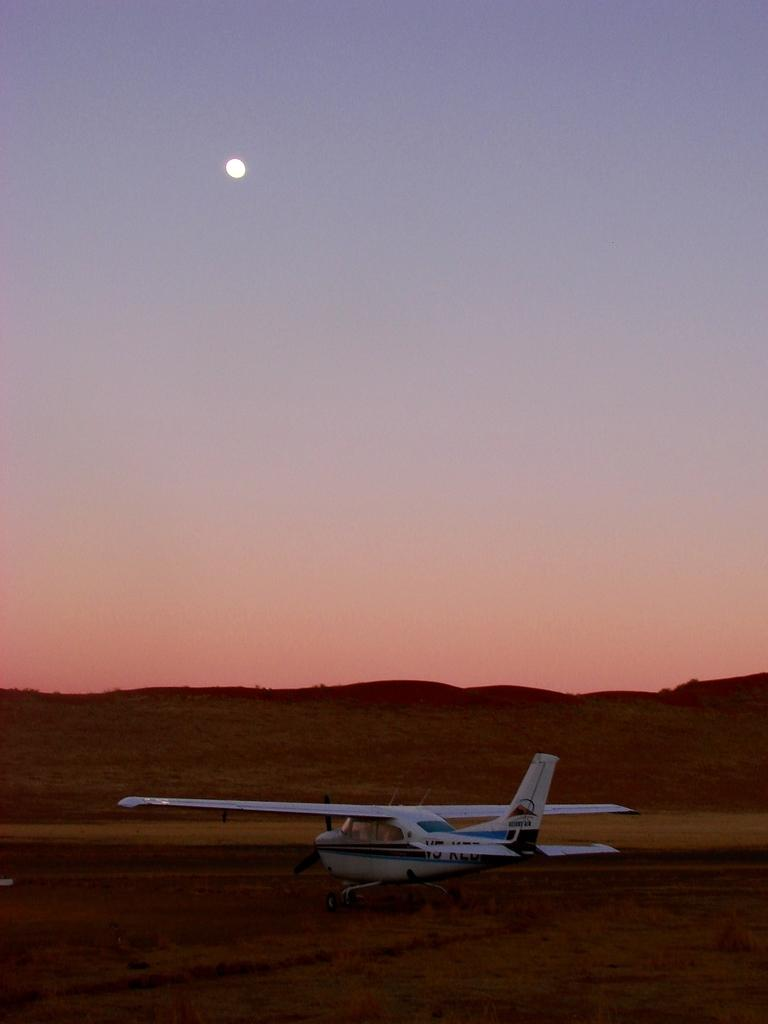What is the main subject in the foreground of the image? There is a helicopter in the foreground of the image. What can be seen in the middle of the image? There is a structure resembling hills in the middle of the image. What is visible at the top of the image? The sky is visible at the top of the image. Can the sun be seen in the sky? Yes, the sun is observable in the sky. What type of potato is being served on the plate in the image? There is no plate or potato present in the image; it features a helicopter and hills. What is the wax used for in the image? There is no wax present in the image. 